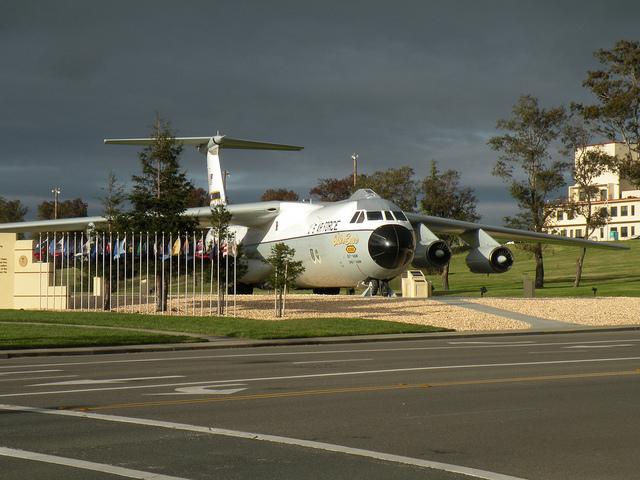Is it a sunny day?
Keep it brief. No. Is this plane grounded for good?
Write a very short answer. Yes. Are there flags in the background?
Keep it brief. Yes. 